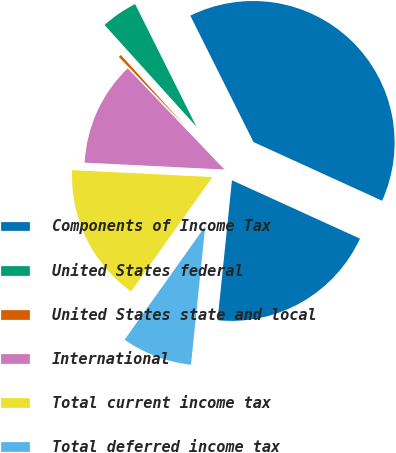<chart> <loc_0><loc_0><loc_500><loc_500><pie_chart><fcel>Components of Income Tax<fcel>United States federal<fcel>United States state and local<fcel>International<fcel>Total current income tax<fcel>Total deferred income tax<fcel>Total income tax expense<nl><fcel>39.19%<fcel>4.32%<fcel>0.45%<fcel>12.07%<fcel>15.95%<fcel>8.2%<fcel>19.82%<nl></chart> 